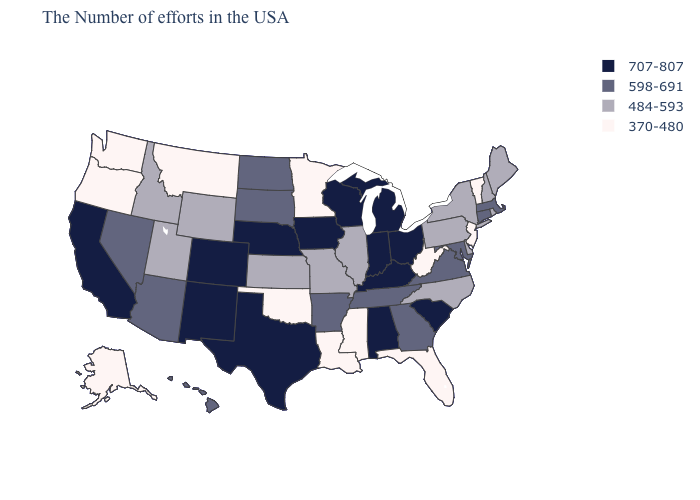Does the map have missing data?
Quick response, please. No. Among the states that border Pennsylvania , does Maryland have the highest value?
Concise answer only. No. What is the value of Kansas?
Short answer required. 484-593. Name the states that have a value in the range 484-593?
Quick response, please. Maine, Rhode Island, New Hampshire, New York, Delaware, Pennsylvania, North Carolina, Illinois, Missouri, Kansas, Wyoming, Utah, Idaho. Does the map have missing data?
Concise answer only. No. Among the states that border Minnesota , does South Dakota have the lowest value?
Give a very brief answer. Yes. Name the states that have a value in the range 598-691?
Keep it brief. Massachusetts, Connecticut, Maryland, Virginia, Georgia, Tennessee, Arkansas, South Dakota, North Dakota, Arizona, Nevada, Hawaii. What is the value of South Carolina?
Write a very short answer. 707-807. Does South Dakota have the highest value in the USA?
Give a very brief answer. No. What is the value of Utah?
Quick response, please. 484-593. What is the value of Ohio?
Quick response, please. 707-807. Does the first symbol in the legend represent the smallest category?
Write a very short answer. No. Does Indiana have the lowest value in the USA?
Concise answer only. No. Among the states that border Rhode Island , which have the highest value?
Give a very brief answer. Massachusetts, Connecticut. 